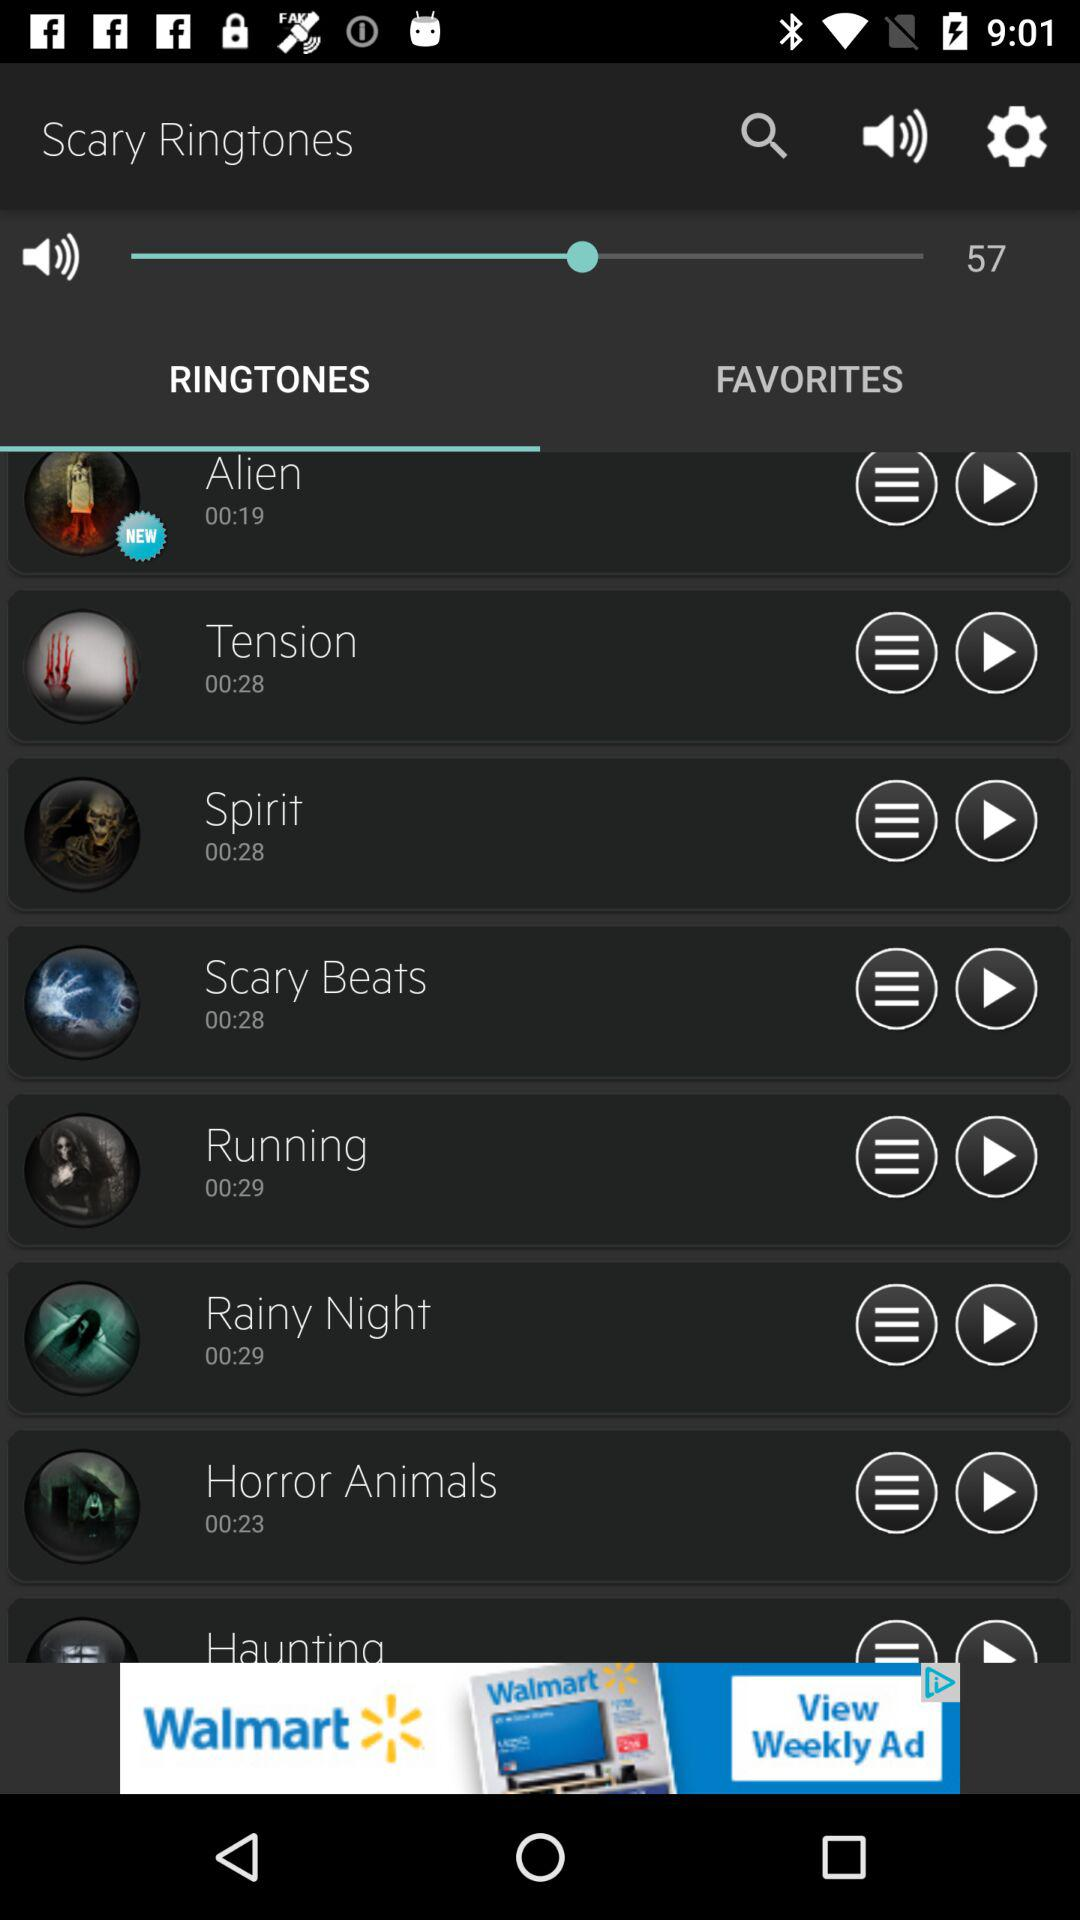What is the duration of "Spirit" ringtone? The duration of "Spirit" ringtone is 28 seconds. 